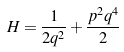<formula> <loc_0><loc_0><loc_500><loc_500>H = \frac { 1 } { 2 q ^ { 2 } } + \frac { p ^ { 2 } q ^ { 4 } } { 2 }</formula> 